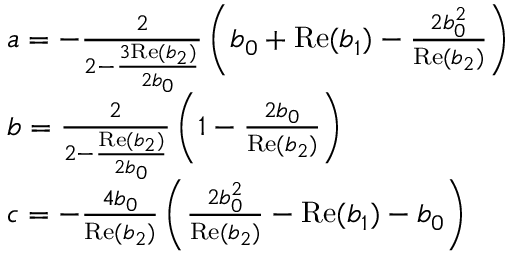<formula> <loc_0><loc_0><loc_500><loc_500>\begin{array} { r l } & { a = - \frac { 2 } { 2 - \frac { 3 R e ( b _ { 2 } ) } { 2 b _ { 0 } } } \left ( b _ { 0 } + R e ( b _ { 1 } ) - \frac { 2 b _ { 0 } ^ { 2 } } { R e ( b _ { 2 } ) } \right ) } \\ & { b = \frac { 2 } { 2 - \frac { R e ( b _ { 2 } ) } { 2 b _ { 0 } } } \left ( 1 - \frac { 2 b _ { 0 } } { R e ( b _ { 2 } ) } \right ) } \\ & { c = - \frac { 4 b _ { 0 } } { R e ( b _ { 2 } ) } \left ( \frac { 2 b _ { 0 } ^ { 2 } } { R e ( b _ { 2 } ) } - R e ( b _ { 1 } ) - b _ { 0 } \right ) } \end{array}</formula> 